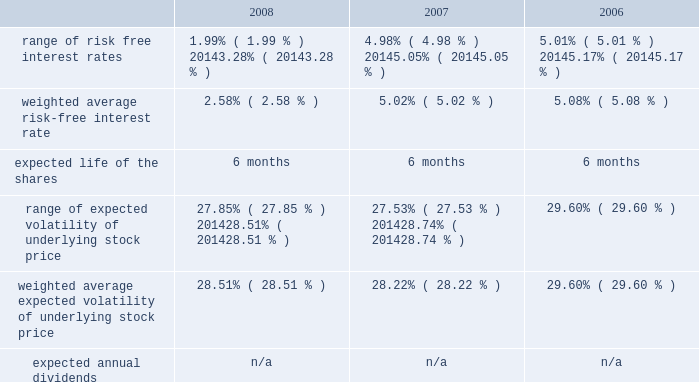American tower corporation and subsidiaries notes to consolidated financial statements 2014 ( continued ) from december 1 through may 31 of each year .
During the 2008 , 2007 and 2006 offering periods employees purchased 55764 , 48886 and 53210 shares , respectively , at weighted average prices per share of $ 30.08 , $ 33.93 and $ 24.98 , respectively .
The fair value of the espp offerings is estimated on the offering period commencement date using a black-scholes pricing model with the expense recognized over the expected life , which is the six month offering period over which employees accumulate payroll deductions to purchase the company 2019s common stock .
The weighted average fair value for the espp shares purchased during 2008 , 2007 and 2006 were $ 7.89 , $ 9.09 and $ 6.79 , respectively .
At december 31 , 2008 , 8.8 million shares remain reserved for future issuance under the plan .
Key assumptions used to apply this pricing model for the years ended december 31 , are as follows: .
13 .
Stockholders 2019 equity warrants 2014in january 2003 , the company issued warrants to purchase approximately 11.4 million shares of its common stock in connection with an offering of 808000 units , each consisting of $ 1000 principal amount at maturity of ati 12.25% ( 12.25 % ) senior subordinated discount notes due 2008 and a warrant to purchase 14.0953 shares of the company 2019s common stock .
These warrants became exercisable on january 29 , 2006 at an exercise price of $ 0.01 per share .
As these warrants expired on august 1 , 2008 , none were outstanding as of december 31 , in august 2005 , the company completed its merger with spectrasite , inc .
And assumed outstanding warrants to purchase shares of spectrasite , inc .
Common stock .
As of the merger completion date , each warrant was exercisable for two shares of spectrasite , inc .
Common stock at an exercise price of $ 32 per warrant .
Upon completion of the merger , each warrant to purchase shares of spectrasite , inc .
Common stock automatically converted into a warrant to purchase shares of the company 2019s common stock , such that upon exercise of each warrant , the holder has a right to receive 3.575 shares of the company 2019s common stock in lieu of each share of spectrasite , inc .
Common stock that would have been receivable under each assumed warrant prior to the merger .
Upon completion of the company 2019s merger with spectrasite , inc. , these warrants were exercisable for approximately 6.8 million shares of common stock .
Of these warrants , warrants to purchase approximately 1.8 million and 2.0 million shares of common stock remained outstanding as of december 31 , 2008 and 2007 , respectively .
These warrants will expire on february 10 , 2010 .
Stock repurchase programs 2014during the year ended december 31 , 2008 , the company repurchased an aggregate of approximately 18.3 million shares of its common stock for an aggregate of $ 697.1 million , including commissions and fees , pursuant to its publicly announced stock repurchase programs , as described below. .
What was the percentage change in the weighted average risk-free interest rate from 2007 to 2008? 
Computations: ((2.58 - 5.02) / 5.02)
Answer: -0.48606. 